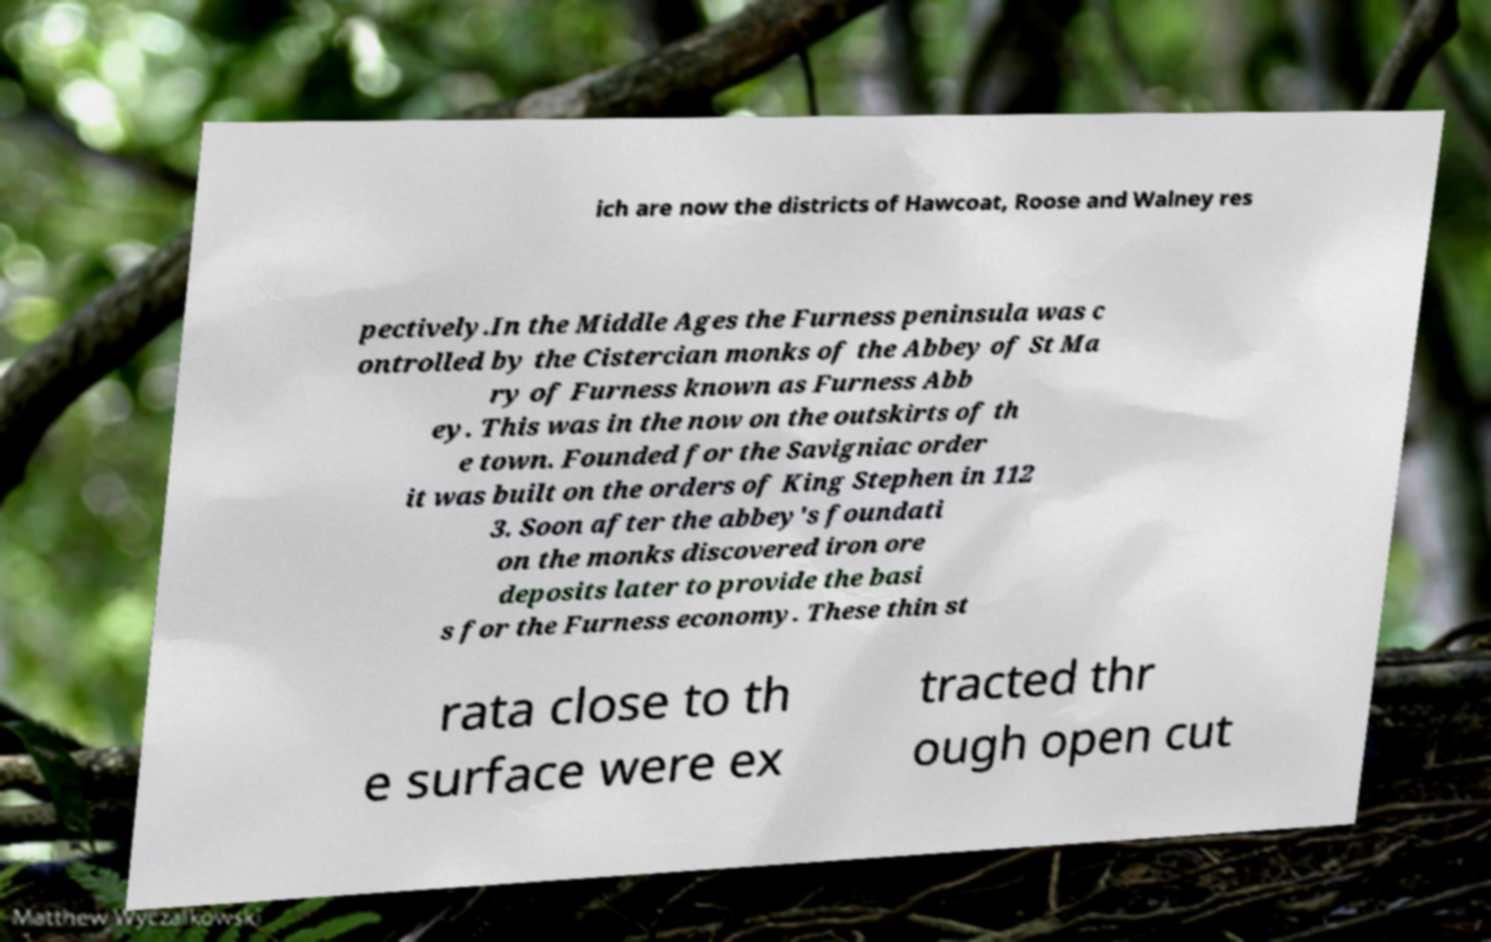Can you read and provide the text displayed in the image?This photo seems to have some interesting text. Can you extract and type it out for me? ich are now the districts of Hawcoat, Roose and Walney res pectively.In the Middle Ages the Furness peninsula was c ontrolled by the Cistercian monks of the Abbey of St Ma ry of Furness known as Furness Abb ey. This was in the now on the outskirts of th e town. Founded for the Savigniac order it was built on the orders of King Stephen in 112 3. Soon after the abbey's foundati on the monks discovered iron ore deposits later to provide the basi s for the Furness economy. These thin st rata close to th e surface were ex tracted thr ough open cut 